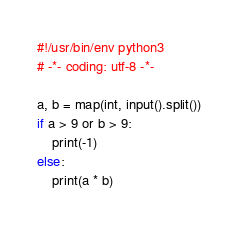Convert code to text. <code><loc_0><loc_0><loc_500><loc_500><_Python_>#!/usr/bin/env python3
# -*- coding: utf-8 -*-

a, b = map(int, input().split())
if a > 9 or b > 9:
    print(-1)
else:
    print(a * b)
</code> 